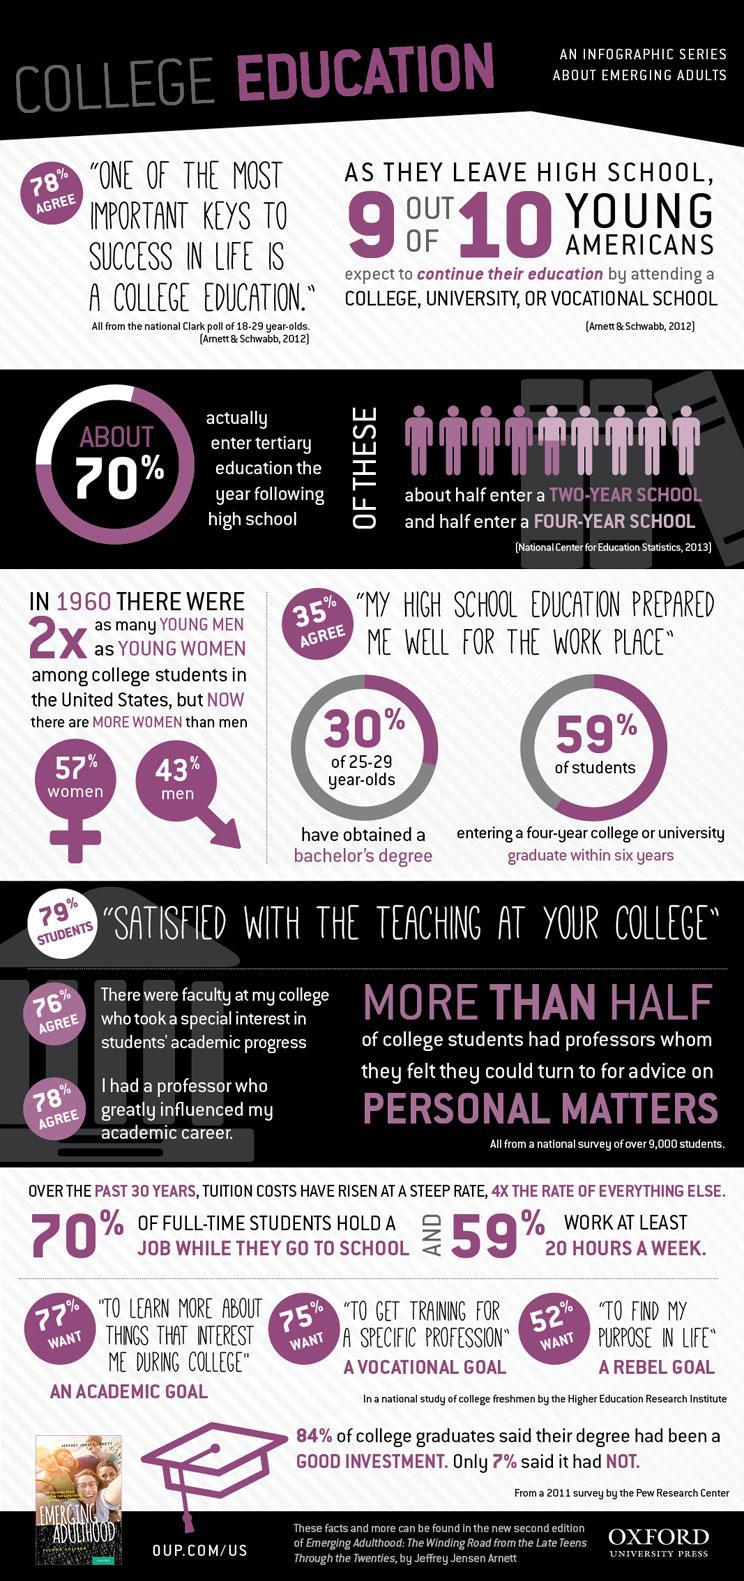What percentage of American students are not happy with the teaching at their college?
Answer the question with a short phrase. 21 What percentage of Americans do not go for ternary education after completing high school? 30 What percentage of Americans does not believe that School education prepared them for work place? 65 What percentage of American college students are men? 43% What percentage of adults does not agree that one of the keys to success is college education? 22 What percentage of students are interested to get trained for a specific profession? 75% What percentage of American college students are women? 57% What percentage of students does not hold a job while they go to school? 30 What percentage of students in the age 25-29 obtained bachelor's degree? 30% How many Americans do not believe that they can continue their education by attending a college? 1 